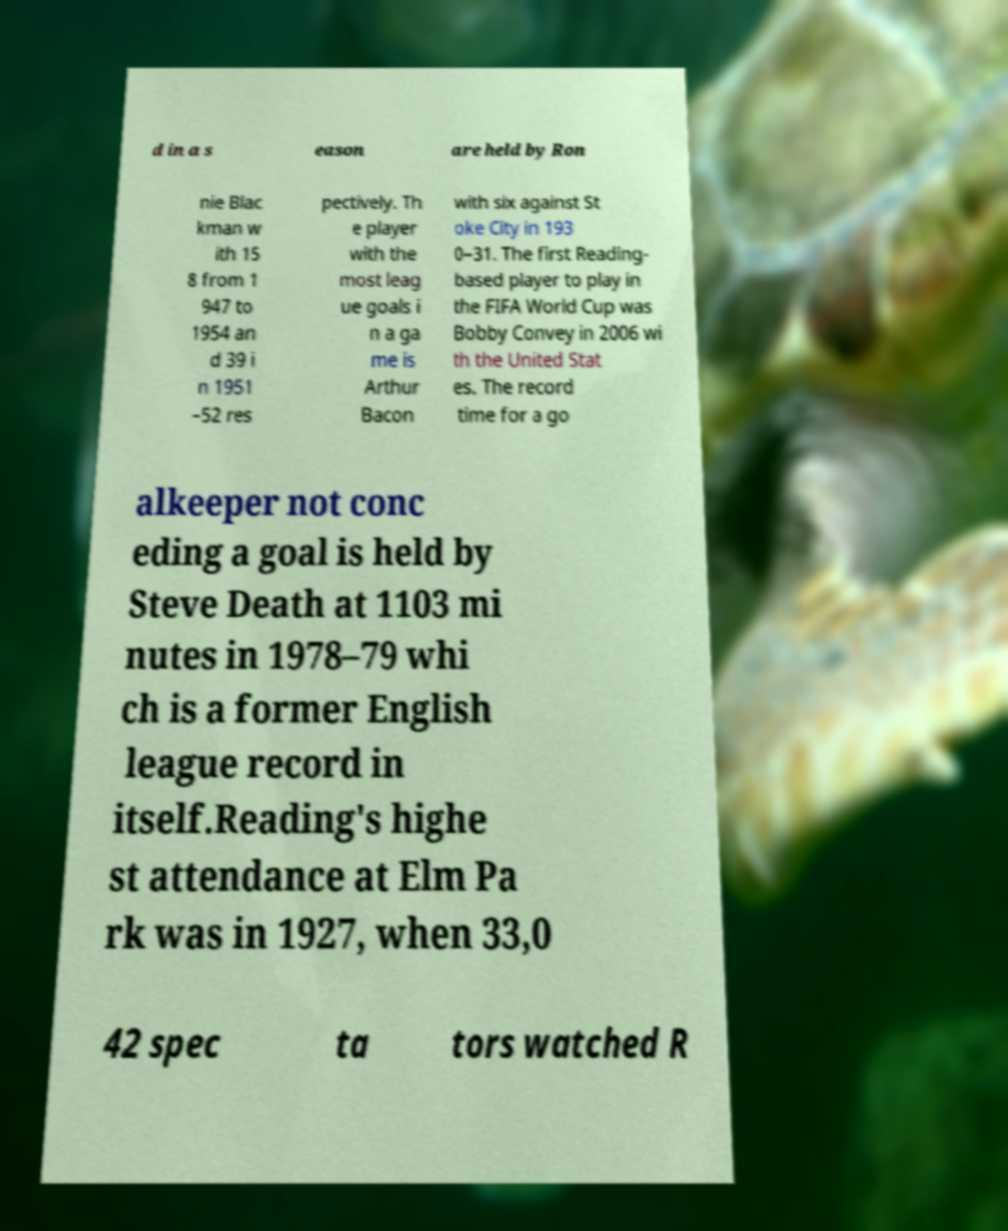Can you accurately transcribe the text from the provided image for me? d in a s eason are held by Ron nie Blac kman w ith 15 8 from 1 947 to 1954 an d 39 i n 1951 –52 res pectively. Th e player with the most leag ue goals i n a ga me is Arthur Bacon with six against St oke City in 193 0–31. The first Reading- based player to play in the FIFA World Cup was Bobby Convey in 2006 wi th the United Stat es. The record time for a go alkeeper not conc eding a goal is held by Steve Death at 1103 mi nutes in 1978–79 whi ch is a former English league record in itself.Reading's highe st attendance at Elm Pa rk was in 1927, when 33,0 42 spec ta tors watched R 